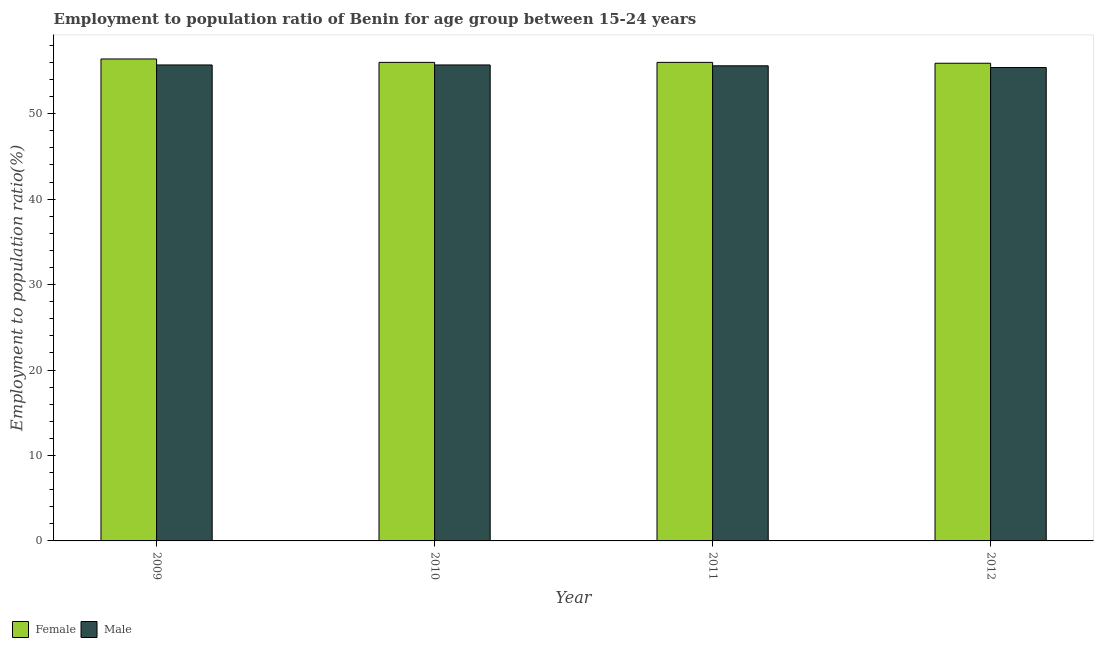Are the number of bars per tick equal to the number of legend labels?
Your response must be concise. Yes. Are the number of bars on each tick of the X-axis equal?
Offer a very short reply. Yes. How many bars are there on the 3rd tick from the left?
Make the answer very short. 2. How many bars are there on the 3rd tick from the right?
Your answer should be compact. 2. What is the label of the 2nd group of bars from the left?
Offer a terse response. 2010. What is the employment to population ratio(male) in 2011?
Your answer should be very brief. 55.6. Across all years, what is the maximum employment to population ratio(female)?
Your answer should be compact. 56.4. Across all years, what is the minimum employment to population ratio(female)?
Offer a terse response. 55.9. In which year was the employment to population ratio(male) maximum?
Make the answer very short. 2009. In which year was the employment to population ratio(male) minimum?
Provide a short and direct response. 2012. What is the total employment to population ratio(female) in the graph?
Your answer should be very brief. 224.3. What is the difference between the employment to population ratio(female) in 2009 and that in 2010?
Offer a terse response. 0.4. What is the difference between the employment to population ratio(male) in 2012 and the employment to population ratio(female) in 2010?
Your answer should be compact. -0.3. What is the average employment to population ratio(male) per year?
Your response must be concise. 55.6. Is the employment to population ratio(male) in 2010 less than that in 2012?
Offer a terse response. No. What is the difference between the highest and the second highest employment to population ratio(male)?
Offer a terse response. 0. What is the difference between the highest and the lowest employment to population ratio(male)?
Offer a terse response. 0.3. How many bars are there?
Provide a succinct answer. 8. Are all the bars in the graph horizontal?
Your response must be concise. No. What is the difference between two consecutive major ticks on the Y-axis?
Provide a short and direct response. 10. Are the values on the major ticks of Y-axis written in scientific E-notation?
Give a very brief answer. No. Does the graph contain grids?
Provide a short and direct response. No. What is the title of the graph?
Keep it short and to the point. Employment to population ratio of Benin for age group between 15-24 years. What is the label or title of the Y-axis?
Offer a terse response. Employment to population ratio(%). What is the Employment to population ratio(%) in Female in 2009?
Your answer should be compact. 56.4. What is the Employment to population ratio(%) of Male in 2009?
Provide a short and direct response. 55.7. What is the Employment to population ratio(%) in Male in 2010?
Provide a short and direct response. 55.7. What is the Employment to population ratio(%) of Male in 2011?
Ensure brevity in your answer.  55.6. What is the Employment to population ratio(%) in Female in 2012?
Keep it short and to the point. 55.9. What is the Employment to population ratio(%) in Male in 2012?
Ensure brevity in your answer.  55.4. Across all years, what is the maximum Employment to population ratio(%) of Female?
Your answer should be compact. 56.4. Across all years, what is the maximum Employment to population ratio(%) of Male?
Provide a succinct answer. 55.7. Across all years, what is the minimum Employment to population ratio(%) in Female?
Your response must be concise. 55.9. Across all years, what is the minimum Employment to population ratio(%) in Male?
Offer a very short reply. 55.4. What is the total Employment to population ratio(%) of Female in the graph?
Provide a succinct answer. 224.3. What is the total Employment to population ratio(%) in Male in the graph?
Offer a very short reply. 222.4. What is the difference between the Employment to population ratio(%) of Female in 2009 and that in 2010?
Your answer should be very brief. 0.4. What is the difference between the Employment to population ratio(%) of Male in 2009 and that in 2010?
Your answer should be very brief. 0. What is the difference between the Employment to population ratio(%) in Female in 2009 and that in 2011?
Ensure brevity in your answer.  0.4. What is the difference between the Employment to population ratio(%) of Male in 2009 and that in 2011?
Keep it short and to the point. 0.1. What is the difference between the Employment to population ratio(%) in Female in 2009 and that in 2012?
Offer a very short reply. 0.5. What is the difference between the Employment to population ratio(%) of Male in 2010 and that in 2011?
Ensure brevity in your answer.  0.1. What is the difference between the Employment to population ratio(%) of Female in 2010 and that in 2012?
Offer a very short reply. 0.1. What is the difference between the Employment to population ratio(%) of Male in 2010 and that in 2012?
Keep it short and to the point. 0.3. What is the difference between the Employment to population ratio(%) of Female in 2011 and that in 2012?
Provide a short and direct response. 0.1. What is the difference between the Employment to population ratio(%) in Female in 2009 and the Employment to population ratio(%) in Male in 2010?
Offer a very short reply. 0.7. What is the difference between the Employment to population ratio(%) in Female in 2009 and the Employment to population ratio(%) in Male in 2012?
Keep it short and to the point. 1. What is the difference between the Employment to population ratio(%) in Female in 2010 and the Employment to population ratio(%) in Male in 2011?
Give a very brief answer. 0.4. What is the average Employment to population ratio(%) of Female per year?
Your answer should be very brief. 56.08. What is the average Employment to population ratio(%) in Male per year?
Offer a terse response. 55.6. What is the ratio of the Employment to population ratio(%) of Female in 2009 to that in 2010?
Give a very brief answer. 1.01. What is the ratio of the Employment to population ratio(%) in Male in 2009 to that in 2010?
Provide a short and direct response. 1. What is the ratio of the Employment to population ratio(%) in Female in 2009 to that in 2011?
Your response must be concise. 1.01. What is the ratio of the Employment to population ratio(%) of Female in 2009 to that in 2012?
Give a very brief answer. 1.01. What is the ratio of the Employment to population ratio(%) in Male in 2009 to that in 2012?
Provide a succinct answer. 1.01. What is the ratio of the Employment to population ratio(%) of Female in 2010 to that in 2011?
Keep it short and to the point. 1. What is the ratio of the Employment to population ratio(%) in Male in 2010 to that in 2011?
Offer a terse response. 1. What is the ratio of the Employment to population ratio(%) of Female in 2010 to that in 2012?
Your response must be concise. 1. What is the ratio of the Employment to population ratio(%) in Male in 2010 to that in 2012?
Your response must be concise. 1.01. What is the ratio of the Employment to population ratio(%) in Male in 2011 to that in 2012?
Ensure brevity in your answer.  1. What is the difference between the highest and the lowest Employment to population ratio(%) of Female?
Keep it short and to the point. 0.5. What is the difference between the highest and the lowest Employment to population ratio(%) in Male?
Provide a succinct answer. 0.3. 